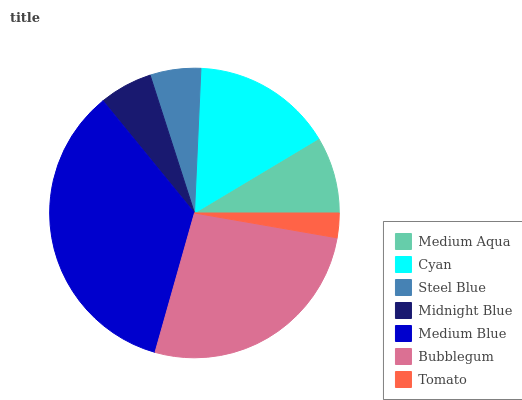Is Tomato the minimum?
Answer yes or no. Yes. Is Medium Blue the maximum?
Answer yes or no. Yes. Is Cyan the minimum?
Answer yes or no. No. Is Cyan the maximum?
Answer yes or no. No. Is Cyan greater than Medium Aqua?
Answer yes or no. Yes. Is Medium Aqua less than Cyan?
Answer yes or no. Yes. Is Medium Aqua greater than Cyan?
Answer yes or no. No. Is Cyan less than Medium Aqua?
Answer yes or no. No. Is Medium Aqua the high median?
Answer yes or no. Yes. Is Medium Aqua the low median?
Answer yes or no. Yes. Is Steel Blue the high median?
Answer yes or no. No. Is Midnight Blue the low median?
Answer yes or no. No. 